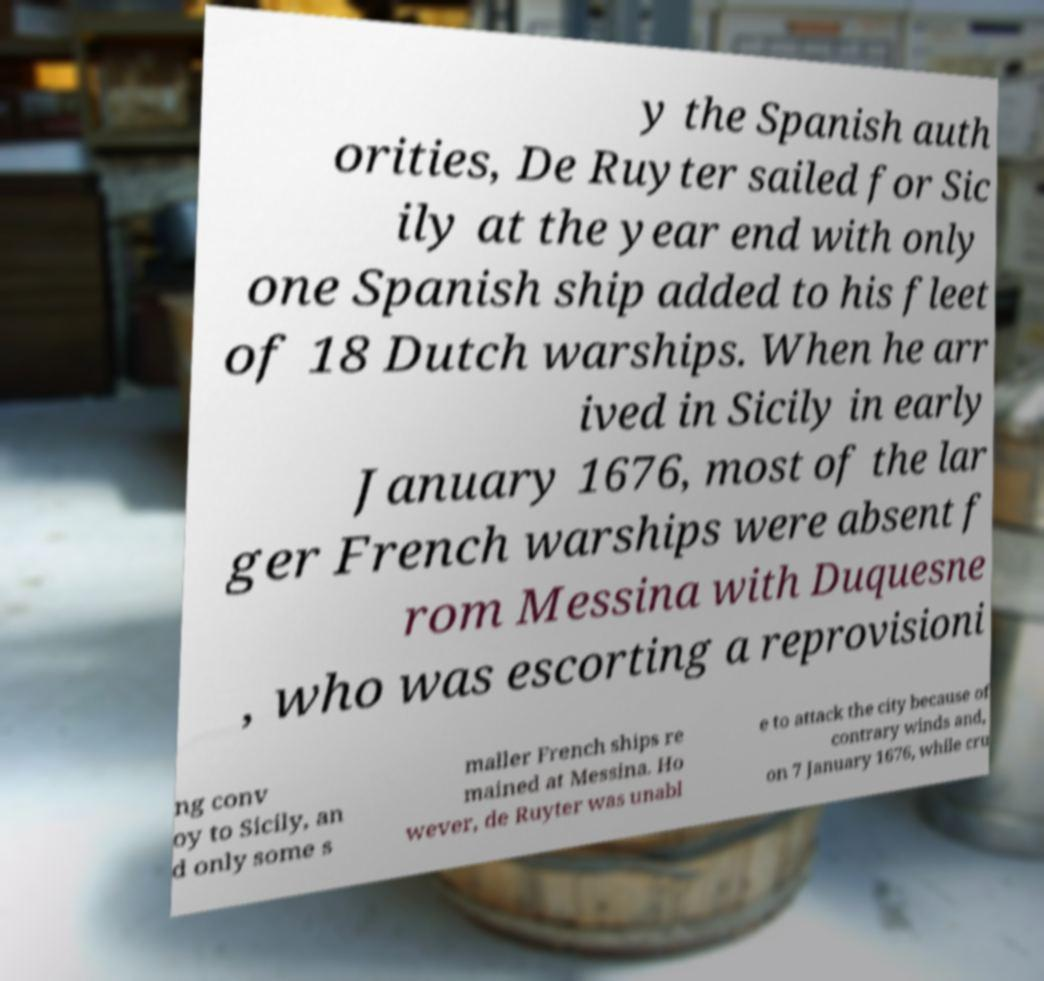Could you assist in decoding the text presented in this image and type it out clearly? y the Spanish auth orities, De Ruyter sailed for Sic ily at the year end with only one Spanish ship added to his fleet of 18 Dutch warships. When he arr ived in Sicily in early January 1676, most of the lar ger French warships were absent f rom Messina with Duquesne , who was escorting a reprovisioni ng conv oy to Sicily, an d only some s maller French ships re mained at Messina. Ho wever, de Ruyter was unabl e to attack the city because of contrary winds and, on 7 January 1676, while cru 